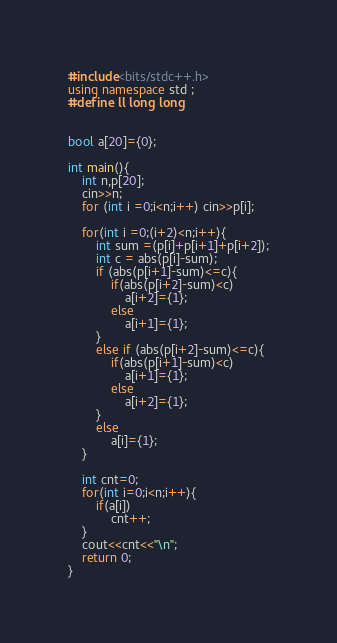Convert code to text. <code><loc_0><loc_0><loc_500><loc_500><_C++_>#include<bits/stdc++.h>
using namespace std ;
#define ll long long


bool a[20]={0};

int main(){
	int n,p[20];
	cin>>n;
	for (int i =0;i<n;i++) cin>>p[i];
	
	for(int i =0;(i+2)<n;i++){
		int sum =(p[i]+p[i+1]+p[i+2]);
		int c = abs(p[i]-sum);
		if (abs(p[i+1]-sum)<=c){
			if(abs(p[i+2]-sum)<c)
				a[i+2]={1};
			else
				a[i+1]={1};
		}		
		else if (abs(p[i+2]-sum)<=c){
			if(abs(p[i+1]-sum)<c)
				a[i+1]={1};
			else
				a[i+2]={1};
		}
		else 
			a[i]={1};
	}
	
	int cnt=0;
	for(int i=0;i<n;i++){
		if(a[i])
			cnt++;
	}
	cout<<cnt<<"\n";
	return 0;
}
</code> 